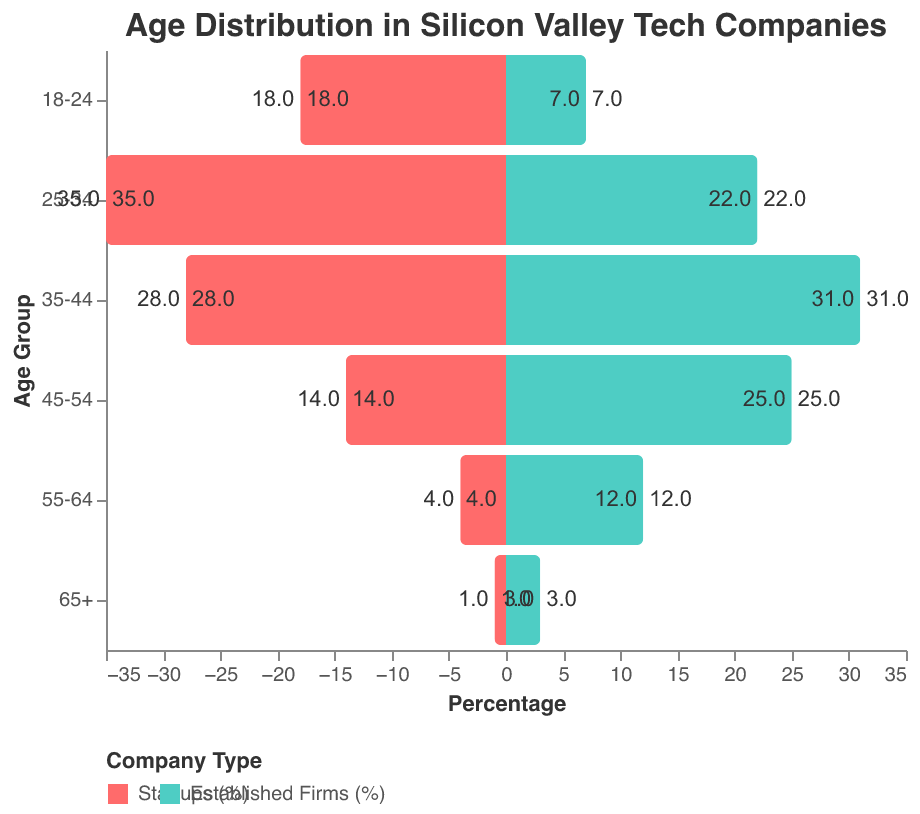What is the title of the figure? The title of the figure is shown at the top in a larger font than the rest of the text. It reads "Age Distribution in Silicon Valley Tech Companies".
Answer: Age Distribution in Silicon Valley Tech Companies Which age group has the highest percentage of employees in startups? The figure shows different age groups on the y-axis, and the percentage of employees for startups is represented by bars extending to the left. The age group 25-34 has the longest bar.
Answer: 25-34 What percentage of employees aged 45-54 work in established firms? Look at the bar corresponding to the age group 45-54 and refer to the tooltip or label on the right of the bar for established firms. It shows 25%.
Answer: 25% How does the percentage of employees aged 18-24 in startups compare to established firms? The bar for startups in the 18-24 age group reaches 18%, while the bar for established firms reaches 7%. Comparing the two, startups have a higher percentage.
Answer: Startups have a higher percentage What is the percentage difference between employees aged 35-44 in startups vs established firms? The figure shows 35-44 age group has 28% in startups and 31% in established firms. Calculate the difference as 31% - 28% = 3%.
Answer: 3% Which company type has a higher percentage of employees aged 55-64? Compare the bars for the 55-64 age group. Startups have 4% while established firms have 12%. Established firms have a higher percentage.
Answer: Established firms How many age groups have a higher percentage in startups than in established firms? Compare each age group’s bars for startups and established firms. The age groups 18-24, 25-34, and 35-44 have higher percentages in startups. That makes 3 age groups.
Answer: 3 For the age group 65+, what is the combined percentage of employees when considering both startups and established firms? The age group 65+ has 1% in startups and 3% in established firms. Adding them gives 1% + 3% = 4%.
Answer: 4% What trend can be observed about the age distribution of employees between startups and established firms? Observing the figure, younger age groups (18-24, 25-34) have a higher percentage in startups, while older age groups (35-44, 45-54, 55-64, 65+) have a higher percentage in established firms.
Answer: Younger employees are more prevalent in startups, while older employees are more prevalent in established firms 